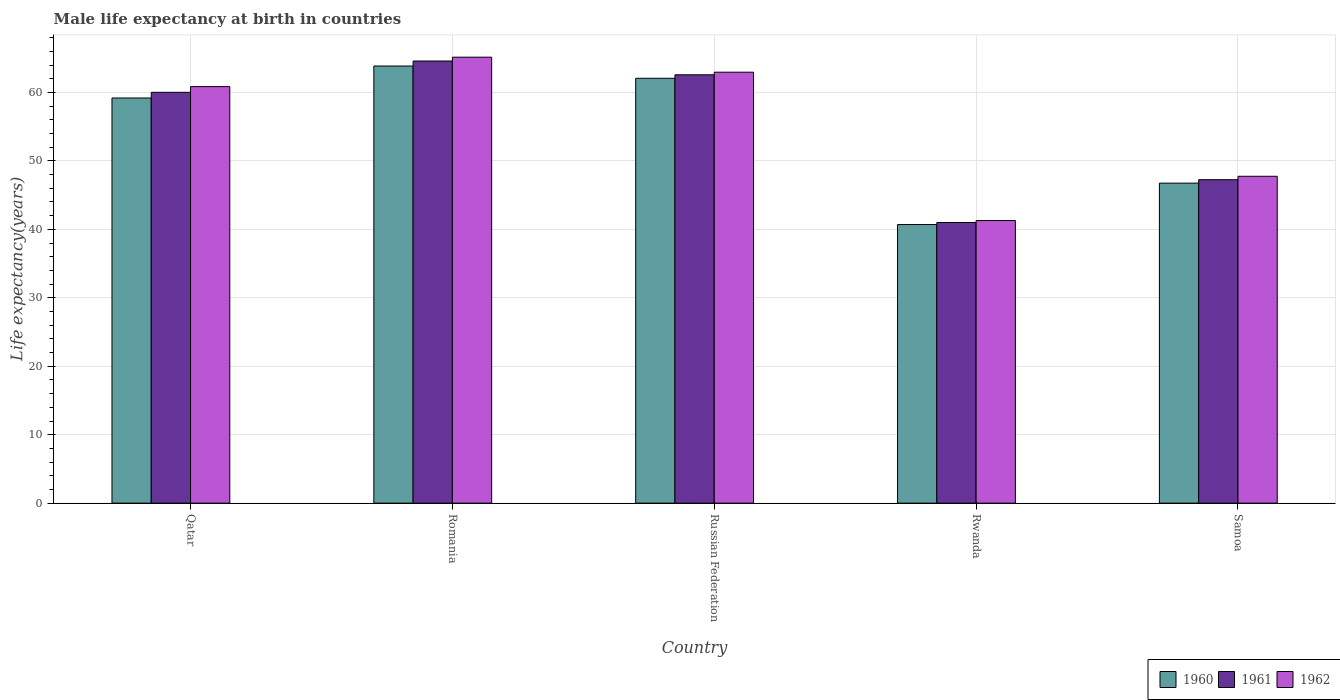Are the number of bars on each tick of the X-axis equal?
Keep it short and to the point. Yes. How many bars are there on the 3rd tick from the left?
Your answer should be compact. 3. How many bars are there on the 2nd tick from the right?
Provide a succinct answer. 3. What is the label of the 3rd group of bars from the left?
Provide a short and direct response. Russian Federation. What is the male life expectancy at birth in 1961 in Rwanda?
Make the answer very short. 41. Across all countries, what is the maximum male life expectancy at birth in 1961?
Offer a terse response. 64.59. Across all countries, what is the minimum male life expectancy at birth in 1960?
Make the answer very short. 40.7. In which country was the male life expectancy at birth in 1961 maximum?
Your response must be concise. Romania. In which country was the male life expectancy at birth in 1961 minimum?
Offer a very short reply. Rwanda. What is the total male life expectancy at birth in 1961 in the graph?
Offer a very short reply. 275.44. What is the difference between the male life expectancy at birth in 1961 in Rwanda and that in Samoa?
Offer a terse response. -6.25. What is the difference between the male life expectancy at birth in 1960 in Samoa and the male life expectancy at birth in 1961 in Russian Federation?
Provide a short and direct response. -15.83. What is the average male life expectancy at birth in 1960 per country?
Your answer should be very brief. 54.51. What is the difference between the male life expectancy at birth of/in 1962 and male life expectancy at birth of/in 1961 in Russian Federation?
Make the answer very short. 0.38. What is the ratio of the male life expectancy at birth in 1960 in Qatar to that in Russian Federation?
Provide a succinct answer. 0.95. Is the male life expectancy at birth in 1962 in Romania less than that in Russian Federation?
Provide a succinct answer. No. What is the difference between the highest and the second highest male life expectancy at birth in 1961?
Offer a very short reply. 4.57. What is the difference between the highest and the lowest male life expectancy at birth in 1961?
Offer a terse response. 23.59. Is the sum of the male life expectancy at birth in 1962 in Russian Federation and Rwanda greater than the maximum male life expectancy at birth in 1961 across all countries?
Keep it short and to the point. Yes. What does the 1st bar from the right in Samoa represents?
Provide a succinct answer. 1962. Is it the case that in every country, the sum of the male life expectancy at birth in 1961 and male life expectancy at birth in 1960 is greater than the male life expectancy at birth in 1962?
Ensure brevity in your answer.  Yes. Are all the bars in the graph horizontal?
Provide a succinct answer. No. How many countries are there in the graph?
Provide a succinct answer. 5. Does the graph contain any zero values?
Your answer should be compact. No. How are the legend labels stacked?
Your response must be concise. Horizontal. What is the title of the graph?
Provide a succinct answer. Male life expectancy at birth in countries. What is the label or title of the X-axis?
Your answer should be very brief. Country. What is the label or title of the Y-axis?
Provide a short and direct response. Life expectancy(years). What is the Life expectancy(years) of 1960 in Qatar?
Make the answer very short. 59.19. What is the Life expectancy(years) in 1961 in Qatar?
Offer a terse response. 60.02. What is the Life expectancy(years) of 1962 in Qatar?
Your answer should be compact. 60.85. What is the Life expectancy(years) in 1960 in Romania?
Offer a very short reply. 63.86. What is the Life expectancy(years) in 1961 in Romania?
Ensure brevity in your answer.  64.59. What is the Life expectancy(years) in 1962 in Romania?
Your response must be concise. 65.15. What is the Life expectancy(years) in 1960 in Russian Federation?
Keep it short and to the point. 62.07. What is the Life expectancy(years) of 1961 in Russian Federation?
Ensure brevity in your answer.  62.58. What is the Life expectancy(years) of 1962 in Russian Federation?
Make the answer very short. 62.96. What is the Life expectancy(years) in 1960 in Rwanda?
Provide a succinct answer. 40.7. What is the Life expectancy(years) of 1961 in Rwanda?
Your answer should be very brief. 41. What is the Life expectancy(years) of 1962 in Rwanda?
Keep it short and to the point. 41.29. What is the Life expectancy(years) of 1960 in Samoa?
Your answer should be very brief. 46.75. What is the Life expectancy(years) in 1961 in Samoa?
Provide a short and direct response. 47.25. What is the Life expectancy(years) in 1962 in Samoa?
Keep it short and to the point. 47.75. Across all countries, what is the maximum Life expectancy(years) of 1960?
Your response must be concise. 63.86. Across all countries, what is the maximum Life expectancy(years) in 1961?
Your answer should be compact. 64.59. Across all countries, what is the maximum Life expectancy(years) in 1962?
Your answer should be very brief. 65.15. Across all countries, what is the minimum Life expectancy(years) in 1960?
Provide a succinct answer. 40.7. Across all countries, what is the minimum Life expectancy(years) in 1961?
Your answer should be compact. 41. Across all countries, what is the minimum Life expectancy(years) of 1962?
Give a very brief answer. 41.29. What is the total Life expectancy(years) of 1960 in the graph?
Your answer should be compact. 272.57. What is the total Life expectancy(years) of 1961 in the graph?
Offer a very short reply. 275.44. What is the total Life expectancy(years) in 1962 in the graph?
Ensure brevity in your answer.  278. What is the difference between the Life expectancy(years) of 1960 in Qatar and that in Romania?
Your answer should be compact. -4.67. What is the difference between the Life expectancy(years) of 1961 in Qatar and that in Romania?
Your answer should be very brief. -4.57. What is the difference between the Life expectancy(years) in 1962 in Qatar and that in Romania?
Your answer should be compact. -4.3. What is the difference between the Life expectancy(years) of 1960 in Qatar and that in Russian Federation?
Keep it short and to the point. -2.88. What is the difference between the Life expectancy(years) of 1961 in Qatar and that in Russian Federation?
Your answer should be very brief. -2.56. What is the difference between the Life expectancy(years) in 1962 in Qatar and that in Russian Federation?
Keep it short and to the point. -2.11. What is the difference between the Life expectancy(years) of 1960 in Qatar and that in Rwanda?
Offer a terse response. 18.49. What is the difference between the Life expectancy(years) of 1961 in Qatar and that in Rwanda?
Your answer should be very brief. 19.02. What is the difference between the Life expectancy(years) of 1962 in Qatar and that in Rwanda?
Provide a short and direct response. 19.57. What is the difference between the Life expectancy(years) of 1960 in Qatar and that in Samoa?
Offer a terse response. 12.44. What is the difference between the Life expectancy(years) of 1961 in Qatar and that in Samoa?
Provide a succinct answer. 12.77. What is the difference between the Life expectancy(years) in 1962 in Qatar and that in Samoa?
Make the answer very short. 13.1. What is the difference between the Life expectancy(years) of 1960 in Romania and that in Russian Federation?
Offer a terse response. 1.79. What is the difference between the Life expectancy(years) in 1961 in Romania and that in Russian Federation?
Provide a succinct answer. 2.01. What is the difference between the Life expectancy(years) in 1962 in Romania and that in Russian Federation?
Your response must be concise. 2.19. What is the difference between the Life expectancy(years) in 1960 in Romania and that in Rwanda?
Provide a short and direct response. 23.16. What is the difference between the Life expectancy(years) in 1961 in Romania and that in Rwanda?
Provide a short and direct response. 23.59. What is the difference between the Life expectancy(years) of 1962 in Romania and that in Rwanda?
Ensure brevity in your answer.  23.87. What is the difference between the Life expectancy(years) in 1960 in Romania and that in Samoa?
Make the answer very short. 17.11. What is the difference between the Life expectancy(years) of 1961 in Romania and that in Samoa?
Offer a very short reply. 17.34. What is the difference between the Life expectancy(years) in 1962 in Romania and that in Samoa?
Offer a very short reply. 17.4. What is the difference between the Life expectancy(years) of 1960 in Russian Federation and that in Rwanda?
Your answer should be compact. 21.37. What is the difference between the Life expectancy(years) in 1961 in Russian Federation and that in Rwanda?
Provide a short and direct response. 21.58. What is the difference between the Life expectancy(years) of 1962 in Russian Federation and that in Rwanda?
Give a very brief answer. 21.67. What is the difference between the Life expectancy(years) in 1960 in Russian Federation and that in Samoa?
Offer a terse response. 15.32. What is the difference between the Life expectancy(years) in 1961 in Russian Federation and that in Samoa?
Offer a very short reply. 15.33. What is the difference between the Life expectancy(years) of 1962 in Russian Federation and that in Samoa?
Ensure brevity in your answer.  15.21. What is the difference between the Life expectancy(years) of 1960 in Rwanda and that in Samoa?
Keep it short and to the point. -6.05. What is the difference between the Life expectancy(years) in 1961 in Rwanda and that in Samoa?
Your response must be concise. -6.25. What is the difference between the Life expectancy(years) in 1962 in Rwanda and that in Samoa?
Provide a short and direct response. -6.46. What is the difference between the Life expectancy(years) of 1960 in Qatar and the Life expectancy(years) of 1961 in Romania?
Make the answer very short. -5.4. What is the difference between the Life expectancy(years) of 1960 in Qatar and the Life expectancy(years) of 1962 in Romania?
Ensure brevity in your answer.  -5.96. What is the difference between the Life expectancy(years) in 1961 in Qatar and the Life expectancy(years) in 1962 in Romania?
Give a very brief answer. -5.13. What is the difference between the Life expectancy(years) of 1960 in Qatar and the Life expectancy(years) of 1961 in Russian Federation?
Your answer should be compact. -3.39. What is the difference between the Life expectancy(years) of 1960 in Qatar and the Life expectancy(years) of 1962 in Russian Federation?
Offer a terse response. -3.77. What is the difference between the Life expectancy(years) in 1961 in Qatar and the Life expectancy(years) in 1962 in Russian Federation?
Your answer should be compact. -2.94. What is the difference between the Life expectancy(years) of 1960 in Qatar and the Life expectancy(years) of 1961 in Rwanda?
Keep it short and to the point. 18.19. What is the difference between the Life expectancy(years) in 1960 in Qatar and the Life expectancy(years) in 1962 in Rwanda?
Keep it short and to the point. 17.9. What is the difference between the Life expectancy(years) in 1961 in Qatar and the Life expectancy(years) in 1962 in Rwanda?
Provide a succinct answer. 18.73. What is the difference between the Life expectancy(years) of 1960 in Qatar and the Life expectancy(years) of 1961 in Samoa?
Your answer should be compact. 11.94. What is the difference between the Life expectancy(years) of 1960 in Qatar and the Life expectancy(years) of 1962 in Samoa?
Offer a terse response. 11.44. What is the difference between the Life expectancy(years) in 1961 in Qatar and the Life expectancy(years) in 1962 in Samoa?
Provide a short and direct response. 12.27. What is the difference between the Life expectancy(years) of 1960 in Romania and the Life expectancy(years) of 1961 in Russian Federation?
Keep it short and to the point. 1.28. What is the difference between the Life expectancy(years) of 1960 in Romania and the Life expectancy(years) of 1962 in Russian Federation?
Offer a terse response. 0.9. What is the difference between the Life expectancy(years) of 1961 in Romania and the Life expectancy(years) of 1962 in Russian Federation?
Your answer should be compact. 1.63. What is the difference between the Life expectancy(years) in 1960 in Romania and the Life expectancy(years) in 1961 in Rwanda?
Your answer should be very brief. 22.86. What is the difference between the Life expectancy(years) of 1960 in Romania and the Life expectancy(years) of 1962 in Rwanda?
Your answer should be very brief. 22.57. What is the difference between the Life expectancy(years) in 1961 in Romania and the Life expectancy(years) in 1962 in Rwanda?
Offer a terse response. 23.3. What is the difference between the Life expectancy(years) in 1960 in Romania and the Life expectancy(years) in 1961 in Samoa?
Provide a succinct answer. 16.61. What is the difference between the Life expectancy(years) of 1960 in Romania and the Life expectancy(years) of 1962 in Samoa?
Keep it short and to the point. 16.11. What is the difference between the Life expectancy(years) in 1961 in Romania and the Life expectancy(years) in 1962 in Samoa?
Your response must be concise. 16.84. What is the difference between the Life expectancy(years) of 1960 in Russian Federation and the Life expectancy(years) of 1961 in Rwanda?
Your response must be concise. 21.07. What is the difference between the Life expectancy(years) of 1960 in Russian Federation and the Life expectancy(years) of 1962 in Rwanda?
Your response must be concise. 20.78. What is the difference between the Life expectancy(years) in 1961 in Russian Federation and the Life expectancy(years) in 1962 in Rwanda?
Give a very brief answer. 21.29. What is the difference between the Life expectancy(years) in 1960 in Russian Federation and the Life expectancy(years) in 1961 in Samoa?
Your answer should be very brief. 14.82. What is the difference between the Life expectancy(years) in 1960 in Russian Federation and the Life expectancy(years) in 1962 in Samoa?
Your response must be concise. 14.32. What is the difference between the Life expectancy(years) in 1961 in Russian Federation and the Life expectancy(years) in 1962 in Samoa?
Offer a very short reply. 14.83. What is the difference between the Life expectancy(years) of 1960 in Rwanda and the Life expectancy(years) of 1961 in Samoa?
Provide a short and direct response. -6.55. What is the difference between the Life expectancy(years) of 1960 in Rwanda and the Life expectancy(years) of 1962 in Samoa?
Keep it short and to the point. -7.05. What is the difference between the Life expectancy(years) in 1961 in Rwanda and the Life expectancy(years) in 1962 in Samoa?
Your answer should be very brief. -6.75. What is the average Life expectancy(years) in 1960 per country?
Ensure brevity in your answer.  54.51. What is the average Life expectancy(years) of 1961 per country?
Ensure brevity in your answer.  55.09. What is the average Life expectancy(years) in 1962 per country?
Your answer should be very brief. 55.6. What is the difference between the Life expectancy(years) in 1960 and Life expectancy(years) in 1961 in Qatar?
Provide a succinct answer. -0.83. What is the difference between the Life expectancy(years) of 1960 and Life expectancy(years) of 1962 in Qatar?
Make the answer very short. -1.66. What is the difference between the Life expectancy(years) in 1961 and Life expectancy(years) in 1962 in Qatar?
Provide a succinct answer. -0.83. What is the difference between the Life expectancy(years) of 1960 and Life expectancy(years) of 1961 in Romania?
Provide a short and direct response. -0.73. What is the difference between the Life expectancy(years) of 1960 and Life expectancy(years) of 1962 in Romania?
Offer a terse response. -1.29. What is the difference between the Life expectancy(years) in 1961 and Life expectancy(years) in 1962 in Romania?
Give a very brief answer. -0.56. What is the difference between the Life expectancy(years) of 1960 and Life expectancy(years) of 1961 in Russian Federation?
Provide a succinct answer. -0.51. What is the difference between the Life expectancy(years) of 1960 and Life expectancy(years) of 1962 in Russian Federation?
Offer a very short reply. -0.89. What is the difference between the Life expectancy(years) of 1961 and Life expectancy(years) of 1962 in Russian Federation?
Offer a very short reply. -0.38. What is the difference between the Life expectancy(years) of 1960 and Life expectancy(years) of 1961 in Rwanda?
Provide a succinct answer. -0.3. What is the difference between the Life expectancy(years) in 1960 and Life expectancy(years) in 1962 in Rwanda?
Your response must be concise. -0.58. What is the difference between the Life expectancy(years) of 1961 and Life expectancy(years) of 1962 in Rwanda?
Provide a succinct answer. -0.29. What is the difference between the Life expectancy(years) of 1960 and Life expectancy(years) of 1961 in Samoa?
Offer a terse response. -0.5. What is the difference between the Life expectancy(years) in 1961 and Life expectancy(years) in 1962 in Samoa?
Your response must be concise. -0.5. What is the ratio of the Life expectancy(years) of 1960 in Qatar to that in Romania?
Provide a succinct answer. 0.93. What is the ratio of the Life expectancy(years) of 1961 in Qatar to that in Romania?
Offer a very short reply. 0.93. What is the ratio of the Life expectancy(years) in 1962 in Qatar to that in Romania?
Ensure brevity in your answer.  0.93. What is the ratio of the Life expectancy(years) in 1960 in Qatar to that in Russian Federation?
Give a very brief answer. 0.95. What is the ratio of the Life expectancy(years) in 1961 in Qatar to that in Russian Federation?
Give a very brief answer. 0.96. What is the ratio of the Life expectancy(years) in 1962 in Qatar to that in Russian Federation?
Offer a terse response. 0.97. What is the ratio of the Life expectancy(years) in 1960 in Qatar to that in Rwanda?
Your answer should be compact. 1.45. What is the ratio of the Life expectancy(years) of 1961 in Qatar to that in Rwanda?
Offer a very short reply. 1.46. What is the ratio of the Life expectancy(years) in 1962 in Qatar to that in Rwanda?
Provide a short and direct response. 1.47. What is the ratio of the Life expectancy(years) of 1960 in Qatar to that in Samoa?
Make the answer very short. 1.27. What is the ratio of the Life expectancy(years) of 1961 in Qatar to that in Samoa?
Your answer should be compact. 1.27. What is the ratio of the Life expectancy(years) of 1962 in Qatar to that in Samoa?
Your answer should be compact. 1.27. What is the ratio of the Life expectancy(years) of 1960 in Romania to that in Russian Federation?
Make the answer very short. 1.03. What is the ratio of the Life expectancy(years) of 1961 in Romania to that in Russian Federation?
Give a very brief answer. 1.03. What is the ratio of the Life expectancy(years) in 1962 in Romania to that in Russian Federation?
Offer a terse response. 1.03. What is the ratio of the Life expectancy(years) in 1960 in Romania to that in Rwanda?
Provide a succinct answer. 1.57. What is the ratio of the Life expectancy(years) in 1961 in Romania to that in Rwanda?
Ensure brevity in your answer.  1.58. What is the ratio of the Life expectancy(years) in 1962 in Romania to that in Rwanda?
Ensure brevity in your answer.  1.58. What is the ratio of the Life expectancy(years) of 1960 in Romania to that in Samoa?
Your answer should be compact. 1.37. What is the ratio of the Life expectancy(years) in 1961 in Romania to that in Samoa?
Give a very brief answer. 1.37. What is the ratio of the Life expectancy(years) in 1962 in Romania to that in Samoa?
Offer a very short reply. 1.36. What is the ratio of the Life expectancy(years) of 1960 in Russian Federation to that in Rwanda?
Offer a terse response. 1.52. What is the ratio of the Life expectancy(years) in 1961 in Russian Federation to that in Rwanda?
Give a very brief answer. 1.53. What is the ratio of the Life expectancy(years) of 1962 in Russian Federation to that in Rwanda?
Your answer should be compact. 1.52. What is the ratio of the Life expectancy(years) of 1960 in Russian Federation to that in Samoa?
Provide a short and direct response. 1.33. What is the ratio of the Life expectancy(years) in 1961 in Russian Federation to that in Samoa?
Offer a very short reply. 1.32. What is the ratio of the Life expectancy(years) of 1962 in Russian Federation to that in Samoa?
Offer a very short reply. 1.32. What is the ratio of the Life expectancy(years) of 1960 in Rwanda to that in Samoa?
Offer a terse response. 0.87. What is the ratio of the Life expectancy(years) of 1961 in Rwanda to that in Samoa?
Offer a terse response. 0.87. What is the ratio of the Life expectancy(years) of 1962 in Rwanda to that in Samoa?
Your response must be concise. 0.86. What is the difference between the highest and the second highest Life expectancy(years) in 1960?
Your answer should be very brief. 1.79. What is the difference between the highest and the second highest Life expectancy(years) of 1961?
Your answer should be compact. 2.01. What is the difference between the highest and the second highest Life expectancy(years) of 1962?
Ensure brevity in your answer.  2.19. What is the difference between the highest and the lowest Life expectancy(years) in 1960?
Your response must be concise. 23.16. What is the difference between the highest and the lowest Life expectancy(years) in 1961?
Give a very brief answer. 23.59. What is the difference between the highest and the lowest Life expectancy(years) of 1962?
Keep it short and to the point. 23.87. 